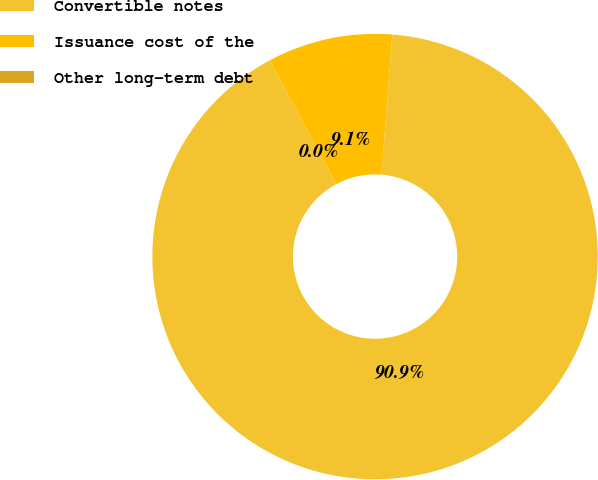<chart> <loc_0><loc_0><loc_500><loc_500><pie_chart><fcel>Convertible notes<fcel>Issuance cost of the<fcel>Other long-term debt<nl><fcel>90.9%<fcel>9.09%<fcel>0.0%<nl></chart> 